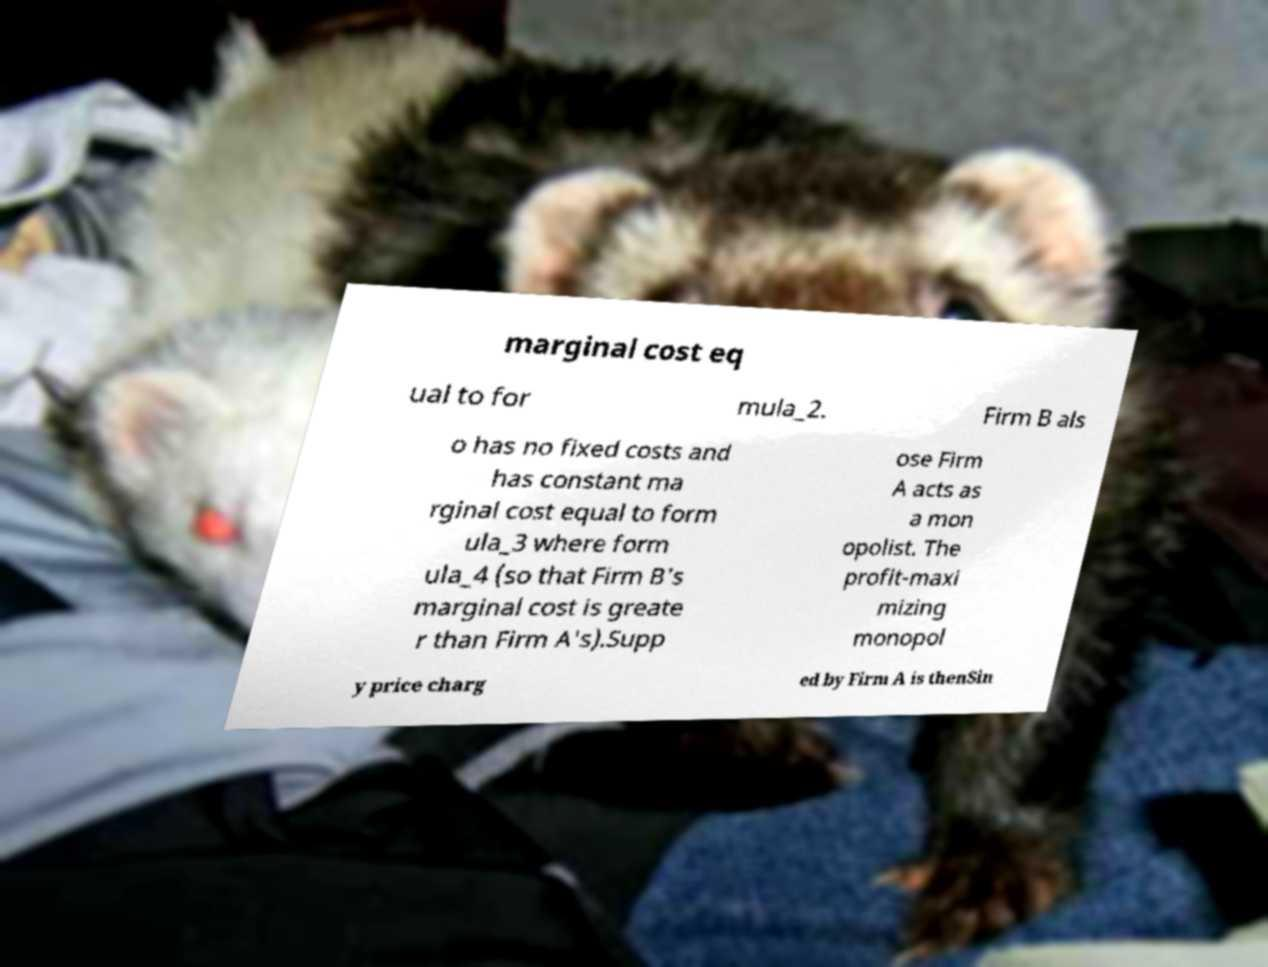I need the written content from this picture converted into text. Can you do that? marginal cost eq ual to for mula_2. Firm B als o has no fixed costs and has constant ma rginal cost equal to form ula_3 where form ula_4 (so that Firm B's marginal cost is greate r than Firm A's).Supp ose Firm A acts as a mon opolist. The profit-maxi mizing monopol y price charg ed by Firm A is thenSin 